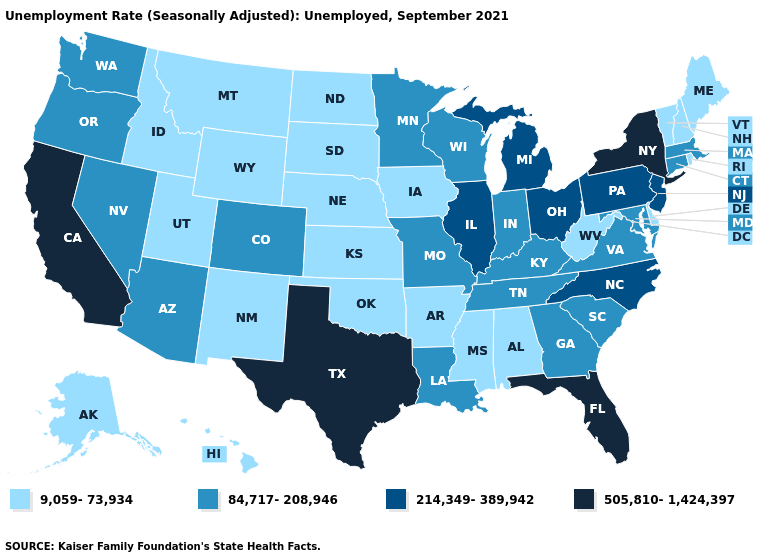Name the states that have a value in the range 9,059-73,934?
Be succinct. Alabama, Alaska, Arkansas, Delaware, Hawaii, Idaho, Iowa, Kansas, Maine, Mississippi, Montana, Nebraska, New Hampshire, New Mexico, North Dakota, Oklahoma, Rhode Island, South Dakota, Utah, Vermont, West Virginia, Wyoming. Name the states that have a value in the range 214,349-389,942?
Short answer required. Illinois, Michigan, New Jersey, North Carolina, Ohio, Pennsylvania. Is the legend a continuous bar?
Give a very brief answer. No. Name the states that have a value in the range 84,717-208,946?
Keep it brief. Arizona, Colorado, Connecticut, Georgia, Indiana, Kentucky, Louisiana, Maryland, Massachusetts, Minnesota, Missouri, Nevada, Oregon, South Carolina, Tennessee, Virginia, Washington, Wisconsin. Name the states that have a value in the range 84,717-208,946?
Quick response, please. Arizona, Colorado, Connecticut, Georgia, Indiana, Kentucky, Louisiana, Maryland, Massachusetts, Minnesota, Missouri, Nevada, Oregon, South Carolina, Tennessee, Virginia, Washington, Wisconsin. Does Minnesota have a lower value than Florida?
Answer briefly. Yes. Among the states that border West Virginia , does Ohio have the highest value?
Short answer required. Yes. Which states hav the highest value in the South?
Write a very short answer. Florida, Texas. Name the states that have a value in the range 505,810-1,424,397?
Write a very short answer. California, Florida, New York, Texas. Among the states that border Arizona , which have the highest value?
Write a very short answer. California. What is the highest value in the USA?
Quick response, please. 505,810-1,424,397. Among the states that border Nebraska , which have the lowest value?
Write a very short answer. Iowa, Kansas, South Dakota, Wyoming. What is the highest value in the MidWest ?
Be succinct. 214,349-389,942. Does Georgia have the highest value in the USA?
Keep it brief. No. Name the states that have a value in the range 505,810-1,424,397?
Write a very short answer. California, Florida, New York, Texas. 